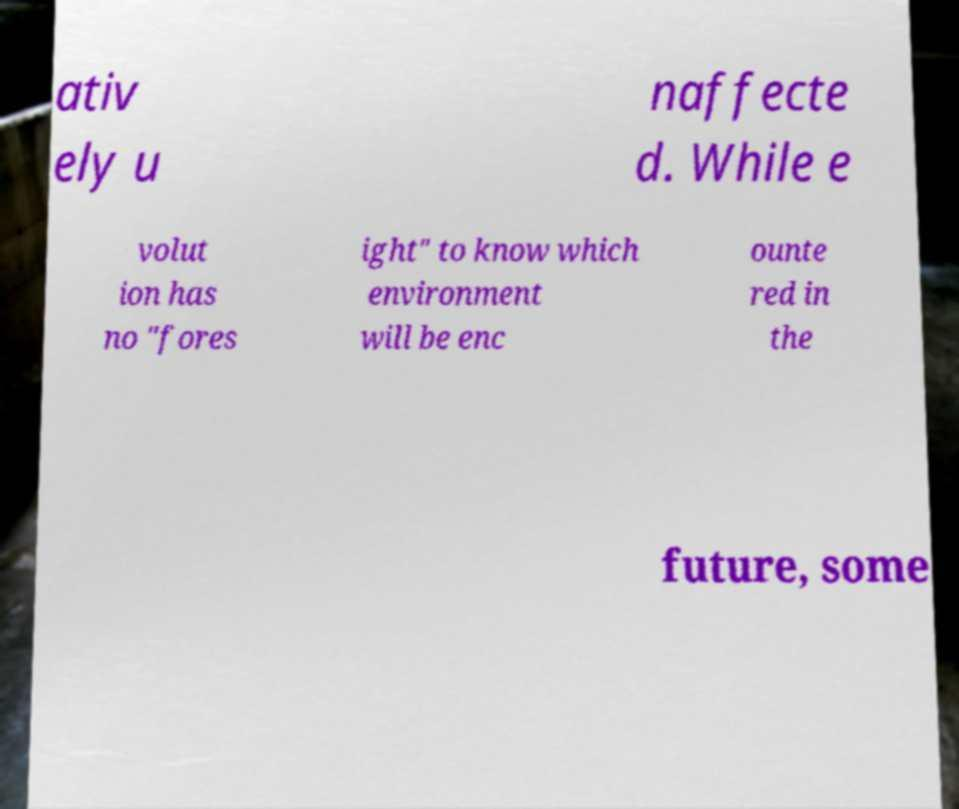For documentation purposes, I need the text within this image transcribed. Could you provide that? ativ ely u naffecte d. While e volut ion has no "fores ight" to know which environment will be enc ounte red in the future, some 